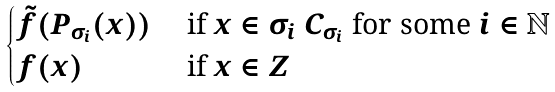<formula> <loc_0><loc_0><loc_500><loc_500>\begin{cases} \tilde { f } ( P _ { \sigma _ { i } } ( x ) ) & \text { if $x \in \sigma_{i} \ C_{\sigma_{i}}$ for some $i \in \mathbb{N}$} \\ f ( x ) & \text { if $x \in Z$} \\ \end{cases}</formula> 